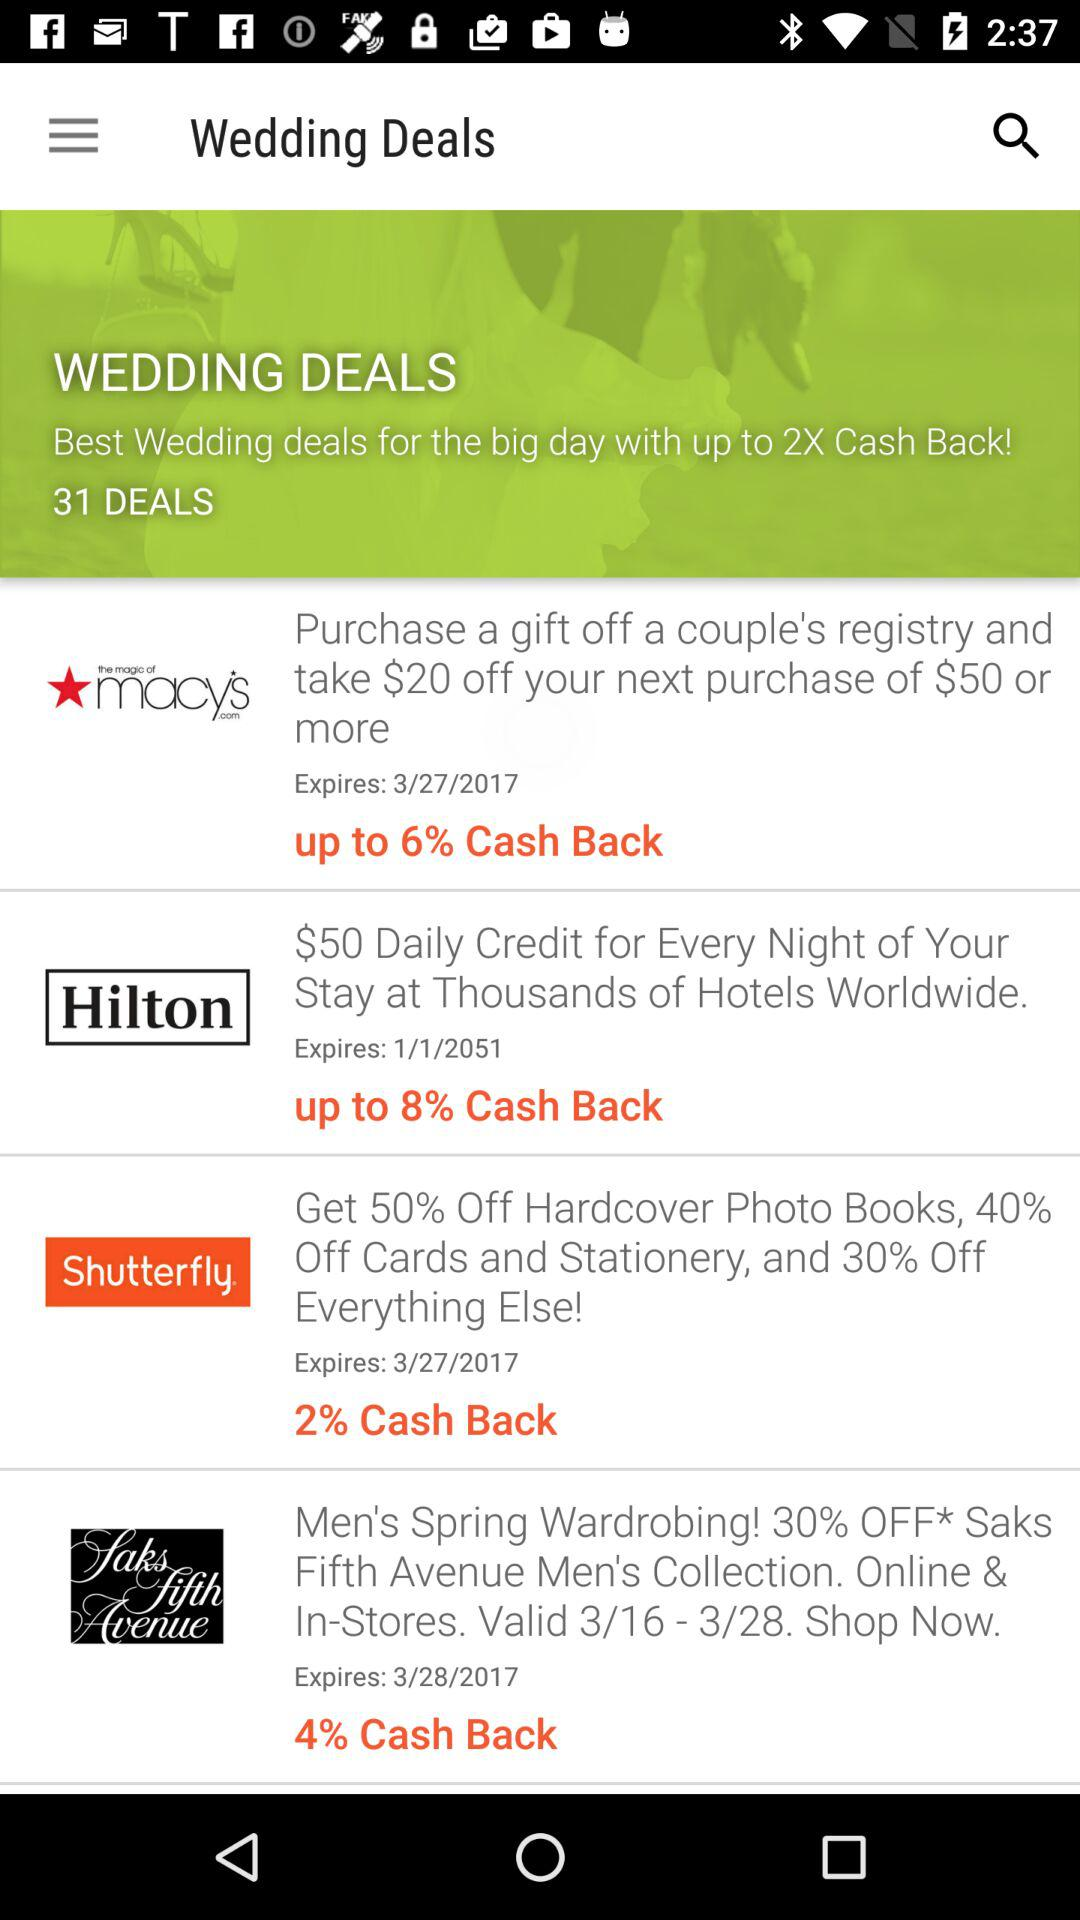What is the expiration date of the offer on "the magic of macys.com"? The expiration date is March 27, 2017. 